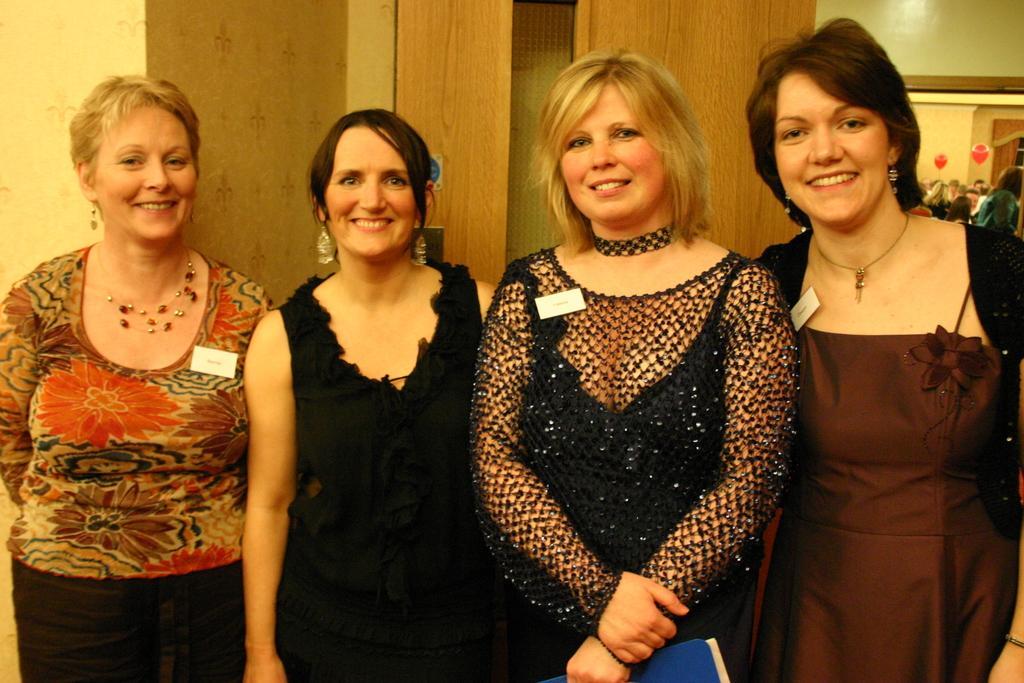In one or two sentences, can you explain what this image depicts? This image consists of four women. In the middle the two women are wearing black dresses. In the background, there is a wall along with the cupboards. To the right, there is a mirror. 